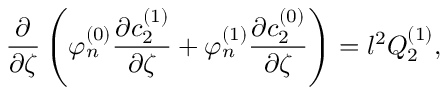Convert formula to latex. <formula><loc_0><loc_0><loc_500><loc_500>\frac { \partial } { \partial \zeta } \left ( \varphi _ { n } ^ { ( 0 ) } \frac { \partial c _ { 2 } ^ { ( 1 ) } } { \partial \zeta } + \varphi _ { n } ^ { ( 1 ) } \frac { \partial c _ { 2 } ^ { ( 0 ) } } { \partial \zeta } \right ) = l ^ { 2 } Q _ { 2 } ^ { ( 1 ) } ,</formula> 